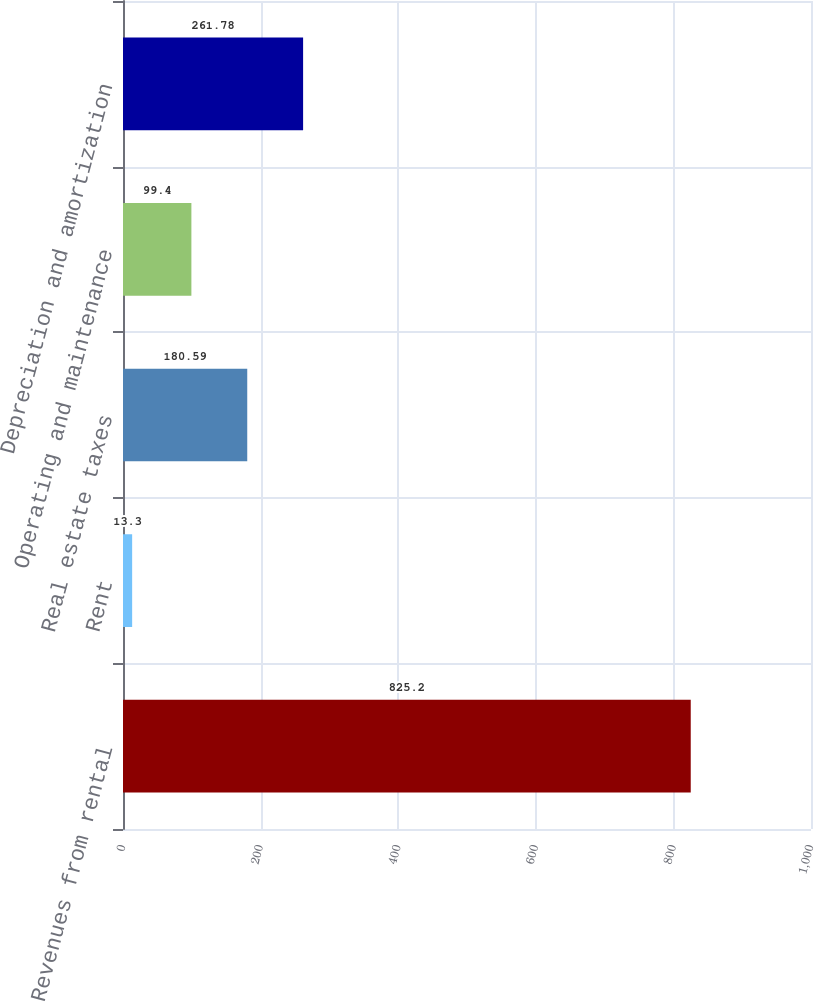Convert chart. <chart><loc_0><loc_0><loc_500><loc_500><bar_chart><fcel>Revenues from rental<fcel>Rent<fcel>Real estate taxes<fcel>Operating and maintenance<fcel>Depreciation and amortization<nl><fcel>825.2<fcel>13.3<fcel>180.59<fcel>99.4<fcel>261.78<nl></chart> 